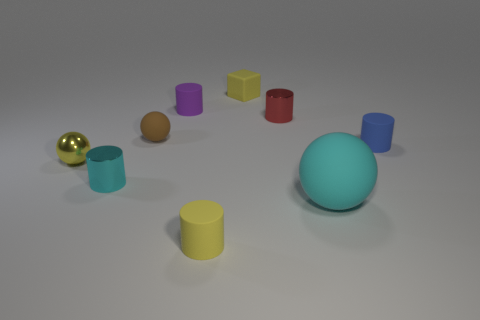What is the material of the tiny ball behind the blue thing?
Provide a succinct answer. Rubber. What is the color of the big thing?
Your response must be concise. Cyan. There is a yellow thing behind the blue matte cylinder; is it the same size as the small purple cylinder?
Make the answer very short. Yes. What is the material of the sphere right of the small yellow rubber thing that is behind the cylinder that is on the right side of the red metal object?
Your response must be concise. Rubber. There is a ball that is in front of the yellow metal object; is its color the same as the metal cylinder that is in front of the red shiny cylinder?
Keep it short and to the point. Yes. The yellow object on the left side of the small matte cylinder behind the blue cylinder is made of what material?
Offer a very short reply. Metal. There is a matte block that is the same size as the yellow rubber cylinder; what is its color?
Offer a very short reply. Yellow. Is the shape of the large cyan rubber object the same as the matte object that is behind the purple matte cylinder?
Make the answer very short. No. What shape is the small rubber object that is the same color as the small cube?
Your response must be concise. Cylinder. What number of tiny metal things are to the left of the rubber cylinder in front of the rubber cylinder that is right of the small red object?
Offer a very short reply. 2. 